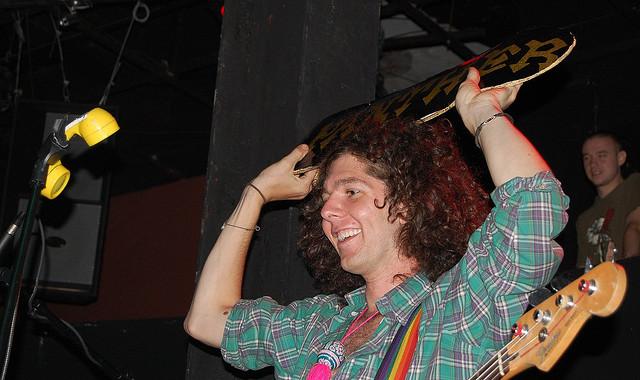Is this man right or left handed?
Quick response, please. Right. What is the person holding over their head?
Give a very brief answer. Skateboard. What race is the person?
Answer briefly. White. What sport are these people going to play?
Concise answer only. Skateboarding. Is this woman wearing a fancy hat?
Short answer required. No. 